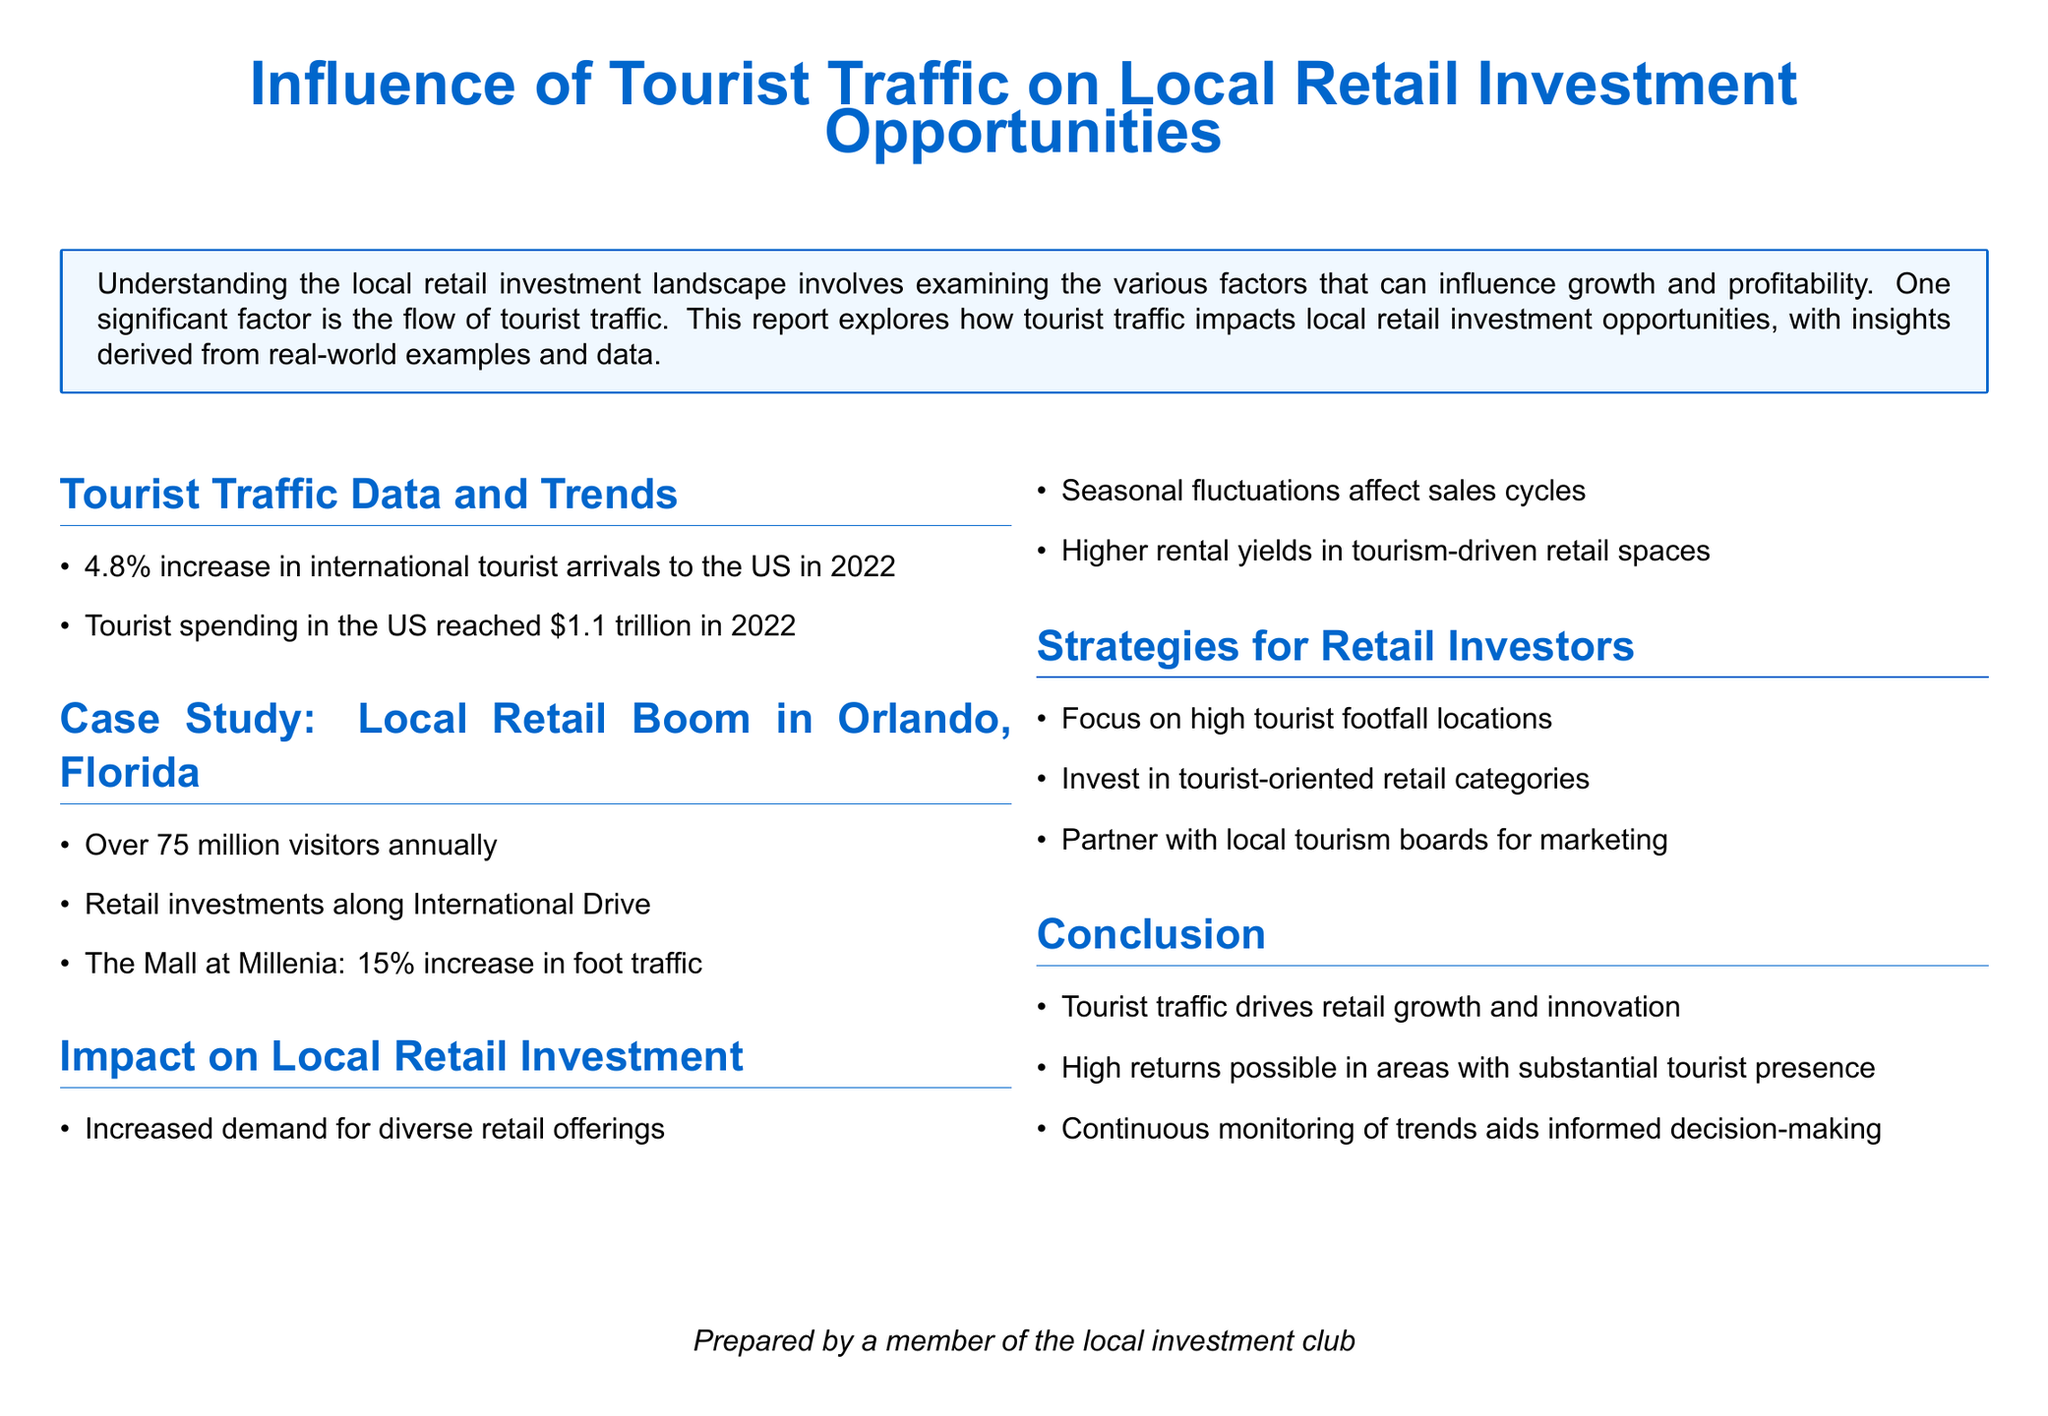What was the percentage increase in international tourist arrivals to the US in 2022? The document states that there was a 4.8% increase in international tourist arrivals to the US in 2022.
Answer: 4.8% What was the total amount spent by tourists in the US in 2022? The report mentions that tourist spending in the US reached $1.1 trillion in 2022.
Answer: $1.1 trillion How many visitors does Orlando, Florida attract annually? According to the case study, Orlando attracts over 75 million visitors annually.
Answer: Over 75 million What percentage increase in foot traffic did The Mall at Millenia experience? The document notes that The Mall at Millenia had a 15% increase in foot traffic.
Answer: 15% What type of retail categories should investors focus on? The report suggests that investors should invest in tourist-oriented retail categories.
Answer: Tourist-oriented retail categories What is the impact of seasonal fluctuations on sales? The document indicates that seasonal fluctuations affect sales cycles.
Answer: Affects sales cycles Which street in Orlando is highlighted for retail investments? International Drive is mentioned as a location for retail investments in Orlando.
Answer: International Drive What drives retail growth and innovation, according to the report? The report concludes that tourist traffic drives retail growth and innovation.
Answer: Tourist traffic 